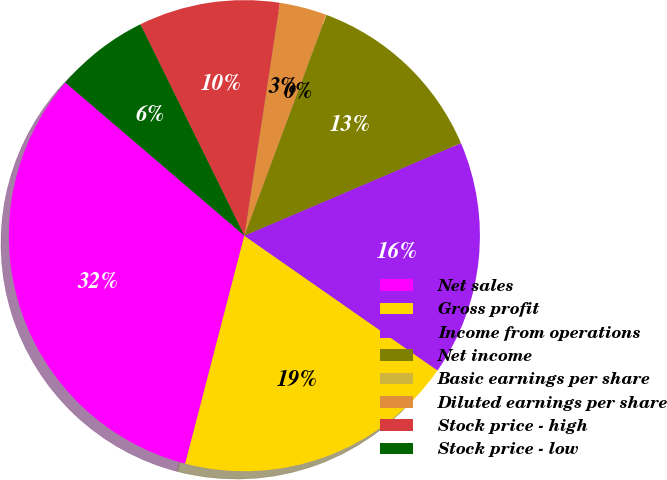Convert chart. <chart><loc_0><loc_0><loc_500><loc_500><pie_chart><fcel>Net sales<fcel>Gross profit<fcel>Income from operations<fcel>Net income<fcel>Basic earnings per share<fcel>Diluted earnings per share<fcel>Stock price - high<fcel>Stock price - low<nl><fcel>32.22%<fcel>19.34%<fcel>16.12%<fcel>12.9%<fcel>0.02%<fcel>3.24%<fcel>9.68%<fcel>6.46%<nl></chart> 